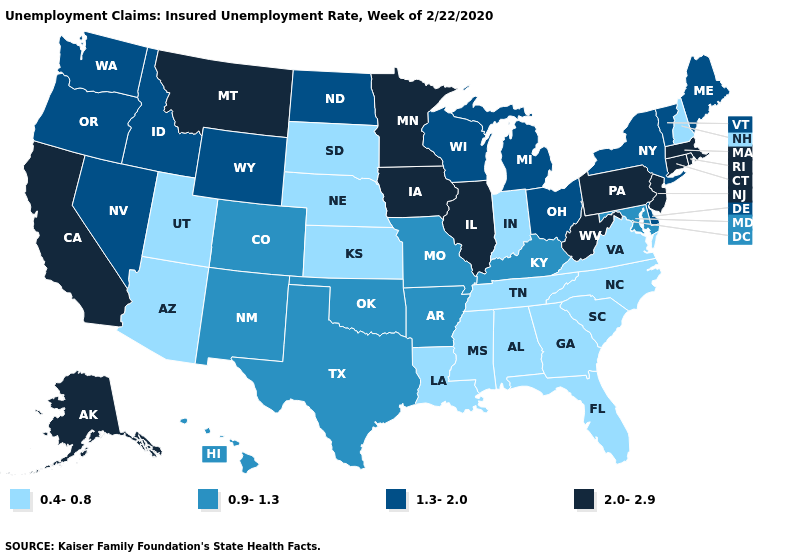Does South Dakota have the lowest value in the MidWest?
Give a very brief answer. Yes. Name the states that have a value in the range 2.0-2.9?
Short answer required. Alaska, California, Connecticut, Illinois, Iowa, Massachusetts, Minnesota, Montana, New Jersey, Pennsylvania, Rhode Island, West Virginia. Name the states that have a value in the range 1.3-2.0?
Answer briefly. Delaware, Idaho, Maine, Michigan, Nevada, New York, North Dakota, Ohio, Oregon, Vermont, Washington, Wisconsin, Wyoming. Does Maryland have the lowest value in the South?
Short answer required. No. Which states have the highest value in the USA?
Give a very brief answer. Alaska, California, Connecticut, Illinois, Iowa, Massachusetts, Minnesota, Montana, New Jersey, Pennsylvania, Rhode Island, West Virginia. Does California have the highest value in the USA?
Write a very short answer. Yes. Is the legend a continuous bar?
Keep it brief. No. What is the highest value in the West ?
Concise answer only. 2.0-2.9. What is the highest value in states that border Nebraska?
Quick response, please. 2.0-2.9. Is the legend a continuous bar?
Quick response, please. No. What is the value of Oregon?
Quick response, please. 1.3-2.0. What is the value of Nevada?
Be succinct. 1.3-2.0. What is the value of North Carolina?
Give a very brief answer. 0.4-0.8. What is the value of Oregon?
Short answer required. 1.3-2.0. What is the highest value in the USA?
Give a very brief answer. 2.0-2.9. 